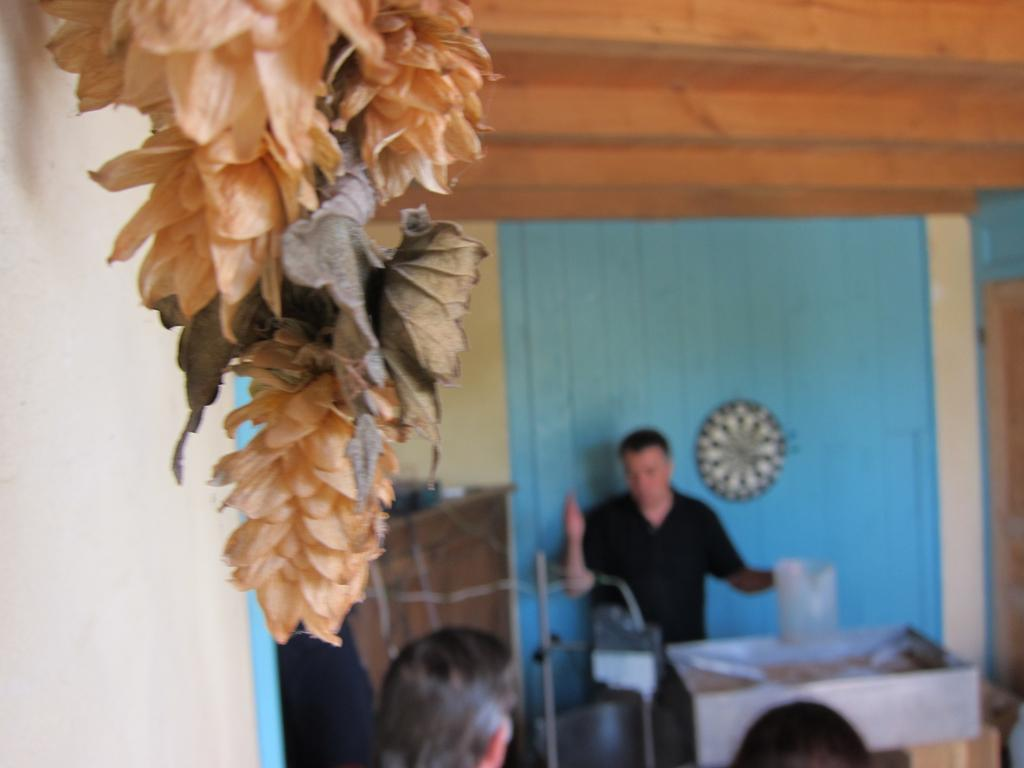What type of plant life can be seen in the image? There are leaves and flowers in the image. How would you describe the background of the image? The background of the image is blurry. Can you identify any human presence in the image? Yes, there are people visible in the background of the image. What else can be seen in the background of the image besides people? There are objects present in the background of the image. What type of education is being taught in the image? There is no indication of any educational activity in the image. 